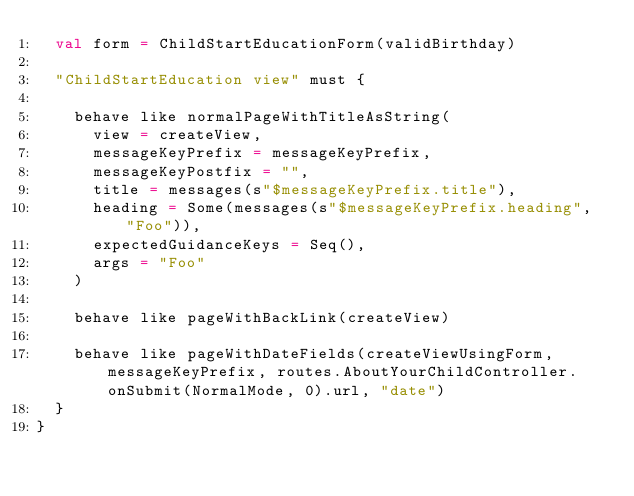Convert code to text. <code><loc_0><loc_0><loc_500><loc_500><_Scala_>  val form = ChildStartEducationForm(validBirthday)

  "ChildStartEducation view" must {

    behave like normalPageWithTitleAsString(
      view = createView,
      messageKeyPrefix = messageKeyPrefix,
      messageKeyPostfix = "",
      title = messages(s"$messageKeyPrefix.title"),
      heading = Some(messages(s"$messageKeyPrefix.heading", "Foo")),
      expectedGuidanceKeys = Seq(),
      args = "Foo"
    )

    behave like pageWithBackLink(createView)

    behave like pageWithDateFields(createViewUsingForm, messageKeyPrefix, routes.AboutYourChildController.onSubmit(NormalMode, 0).url, "date")
  }
}
</code> 